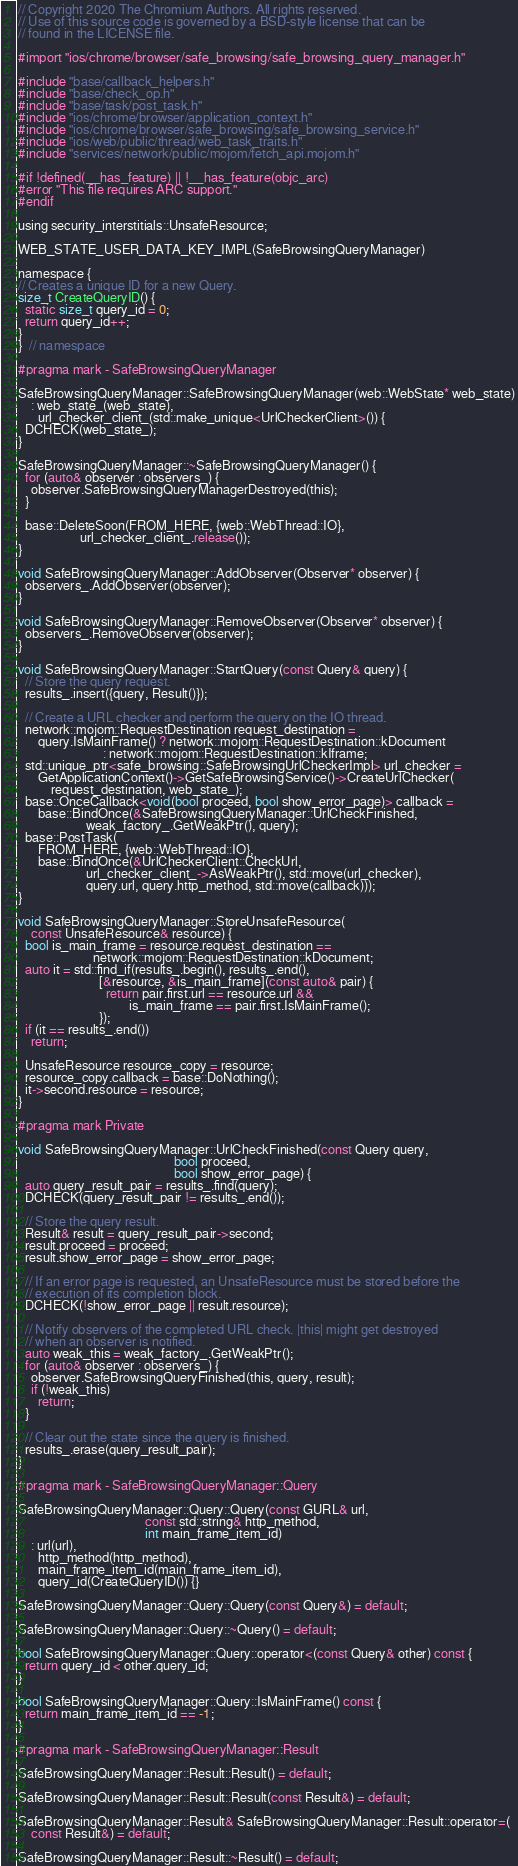<code> <loc_0><loc_0><loc_500><loc_500><_ObjectiveC_>// Copyright 2020 The Chromium Authors. All rights reserved.
// Use of this source code is governed by a BSD-style license that can be
// found in the LICENSE file.

#import "ios/chrome/browser/safe_browsing/safe_browsing_query_manager.h"

#include "base/callback_helpers.h"
#include "base/check_op.h"
#include "base/task/post_task.h"
#include "ios/chrome/browser/application_context.h"
#include "ios/chrome/browser/safe_browsing/safe_browsing_service.h"
#include "ios/web/public/thread/web_task_traits.h"
#include "services/network/public/mojom/fetch_api.mojom.h"

#if !defined(__has_feature) || !__has_feature(objc_arc)
#error "This file requires ARC support."
#endif

using security_interstitials::UnsafeResource;

WEB_STATE_USER_DATA_KEY_IMPL(SafeBrowsingQueryManager)

namespace {
// Creates a unique ID for a new Query.
size_t CreateQueryID() {
  static size_t query_id = 0;
  return query_id++;
}
}  // namespace

#pragma mark - SafeBrowsingQueryManager

SafeBrowsingQueryManager::SafeBrowsingQueryManager(web::WebState* web_state)
    : web_state_(web_state),
      url_checker_client_(std::make_unique<UrlCheckerClient>()) {
  DCHECK(web_state_);
}

SafeBrowsingQueryManager::~SafeBrowsingQueryManager() {
  for (auto& observer : observers_) {
    observer.SafeBrowsingQueryManagerDestroyed(this);
  }

  base::DeleteSoon(FROM_HERE, {web::WebThread::IO},
                   url_checker_client_.release());
}

void SafeBrowsingQueryManager::AddObserver(Observer* observer) {
  observers_.AddObserver(observer);
}

void SafeBrowsingQueryManager::RemoveObserver(Observer* observer) {
  observers_.RemoveObserver(observer);
}

void SafeBrowsingQueryManager::StartQuery(const Query& query) {
  // Store the query request.
  results_.insert({query, Result()});

  // Create a URL checker and perform the query on the IO thread.
  network::mojom::RequestDestination request_destination =
      query.IsMainFrame() ? network::mojom::RequestDestination::kDocument
                          : network::mojom::RequestDestination::kIframe;
  std::unique_ptr<safe_browsing::SafeBrowsingUrlCheckerImpl> url_checker =
      GetApplicationContext()->GetSafeBrowsingService()->CreateUrlChecker(
          request_destination, web_state_);
  base::OnceCallback<void(bool proceed, bool show_error_page)> callback =
      base::BindOnce(&SafeBrowsingQueryManager::UrlCheckFinished,
                     weak_factory_.GetWeakPtr(), query);
  base::PostTask(
      FROM_HERE, {web::WebThread::IO},
      base::BindOnce(&UrlCheckerClient::CheckUrl,
                     url_checker_client_->AsWeakPtr(), std::move(url_checker),
                     query.url, query.http_method, std::move(callback)));
}

void SafeBrowsingQueryManager::StoreUnsafeResource(
    const UnsafeResource& resource) {
  bool is_main_frame = resource.request_destination ==
                       network::mojom::RequestDestination::kDocument;
  auto it = std::find_if(results_.begin(), results_.end(),
                         [&resource, &is_main_frame](const auto& pair) {
                           return pair.first.url == resource.url &&
                                  is_main_frame == pair.first.IsMainFrame();
                         });
  if (it == results_.end())
    return;

  UnsafeResource resource_copy = resource;
  resource_copy.callback = base::DoNothing();
  it->second.resource = resource;
}

#pragma mark Private

void SafeBrowsingQueryManager::UrlCheckFinished(const Query query,
                                                bool proceed,
                                                bool show_error_page) {
  auto query_result_pair = results_.find(query);
  DCHECK(query_result_pair != results_.end());

  // Store the query result.
  Result& result = query_result_pair->second;
  result.proceed = proceed;
  result.show_error_page = show_error_page;

  // If an error page is requested, an UnsafeResource must be stored before the
  // execution of its completion block.
  DCHECK(!show_error_page || result.resource);

  // Notify observers of the completed URL check. |this| might get destroyed
  // when an observer is notified.
  auto weak_this = weak_factory_.GetWeakPtr();
  for (auto& observer : observers_) {
    observer.SafeBrowsingQueryFinished(this, query, result);
    if (!weak_this)
      return;
  }

  // Clear out the state since the query is finished.
  results_.erase(query_result_pair);
}

#pragma mark - SafeBrowsingQueryManager::Query

SafeBrowsingQueryManager::Query::Query(const GURL& url,
                                       const std::string& http_method,
                                       int main_frame_item_id)
    : url(url),
      http_method(http_method),
      main_frame_item_id(main_frame_item_id),
      query_id(CreateQueryID()) {}

SafeBrowsingQueryManager::Query::Query(const Query&) = default;

SafeBrowsingQueryManager::Query::~Query() = default;

bool SafeBrowsingQueryManager::Query::operator<(const Query& other) const {
  return query_id < other.query_id;
}

bool SafeBrowsingQueryManager::Query::IsMainFrame() const {
  return main_frame_item_id == -1;
}

#pragma mark - SafeBrowsingQueryManager::Result

SafeBrowsingQueryManager::Result::Result() = default;

SafeBrowsingQueryManager::Result::Result(const Result&) = default;

SafeBrowsingQueryManager::Result& SafeBrowsingQueryManager::Result::operator=(
    const Result&) = default;

SafeBrowsingQueryManager::Result::~Result() = default;
</code> 